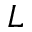<formula> <loc_0><loc_0><loc_500><loc_500>L</formula> 